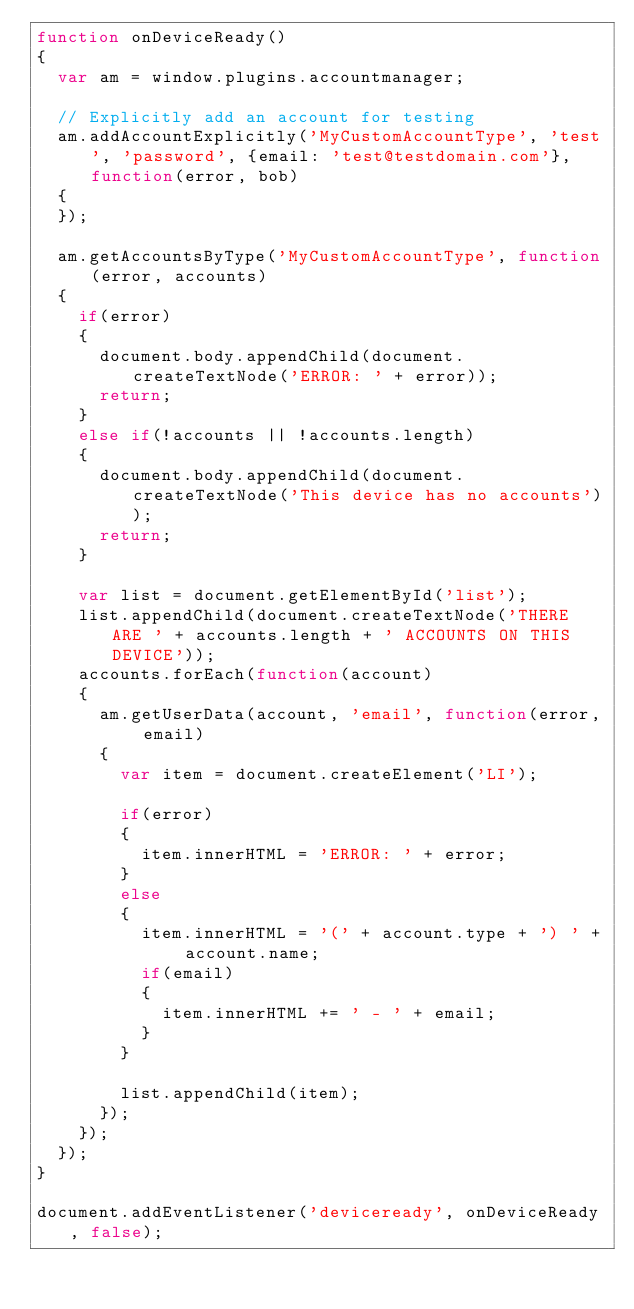Convert code to text. <code><loc_0><loc_0><loc_500><loc_500><_JavaScript_>function onDeviceReady()
{
	var am = window.plugins.accountmanager;

	// Explicitly add an account for testing
	am.addAccountExplicitly('MyCustomAccountType', 'test', 'password', {email: 'test@testdomain.com'}, function(error, bob)
	{
	});

	am.getAccountsByType('MyCustomAccountType', function(error, accounts)
	{
		if(error)
		{
			document.body.appendChild(document.createTextNode('ERROR: ' + error));
			return;
		}
		else if(!accounts || !accounts.length)
		{
			document.body.appendChild(document.createTextNode('This device has no accounts'));
			return;
		}
		
		var list = document.getElementById('list');
		list.appendChild(document.createTextNode('THERE ARE ' + accounts.length + ' ACCOUNTS ON THIS DEVICE'));
		accounts.forEach(function(account)
		{
			am.getUserData(account, 'email', function(error, email)
			{
				var item = document.createElement('LI');
					
				if(error)
				{
					item.innerHTML = 'ERROR: ' + error;
				}
				else
				{
					item.innerHTML = '(' + account.type + ') ' + account.name;
					if(email)
					{
						item.innerHTML += ' - ' + email;
					}
				}

				list.appendChild(item);
			});
		});
	});
}

document.addEventListener('deviceready', onDeviceReady, false);</code> 